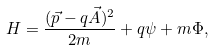<formula> <loc_0><loc_0><loc_500><loc_500>H = \frac { ( \vec { p } - q { \vec { A } } ) ^ { 2 } } { 2 m } + q \psi + m \Phi ,</formula> 